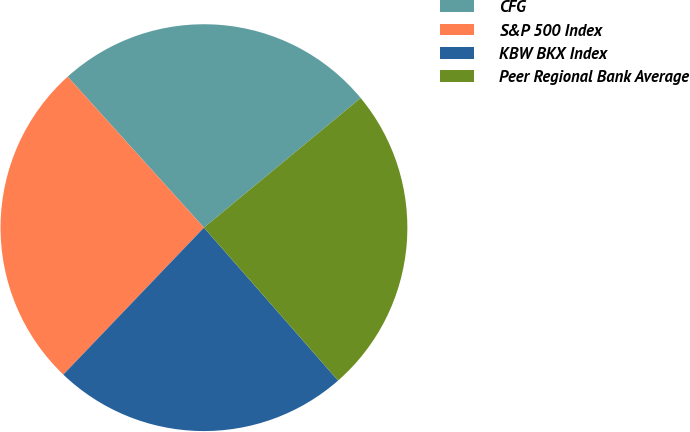<chart> <loc_0><loc_0><loc_500><loc_500><pie_chart><fcel>CFG<fcel>S&P 500 Index<fcel>KBW BKX Index<fcel>Peer Regional Bank Average<nl><fcel>25.69%<fcel>26.16%<fcel>23.61%<fcel>24.54%<nl></chart> 